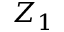<formula> <loc_0><loc_0><loc_500><loc_500>Z _ { 1 }</formula> 